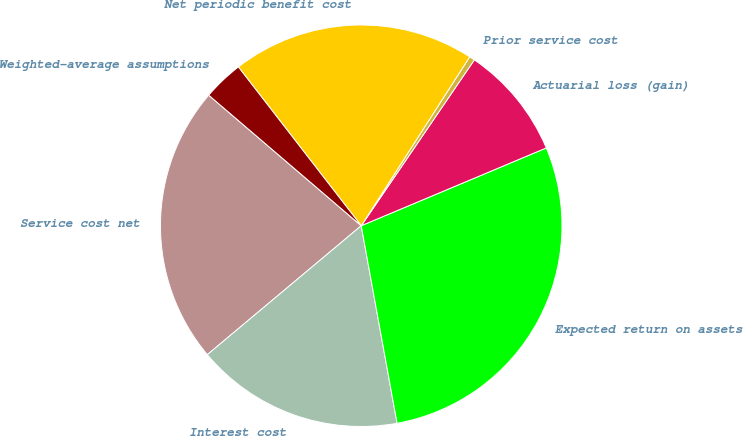Convert chart. <chart><loc_0><loc_0><loc_500><loc_500><pie_chart><fcel>Service cost net<fcel>Interest cost<fcel>Expected return on assets<fcel>Actuarial loss (gain)<fcel>Prior service cost<fcel>Net periodic benefit cost<fcel>Weighted-average assumptions<nl><fcel>22.37%<fcel>16.76%<fcel>28.48%<fcel>9.14%<fcel>0.44%<fcel>19.57%<fcel>3.25%<nl></chart> 